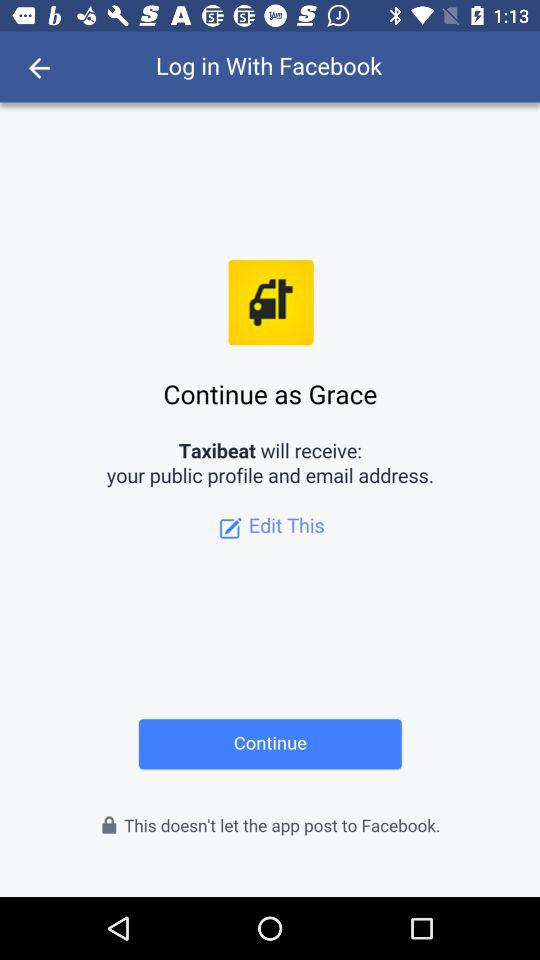Through what application are we logging in? You are logging in through "Facebook". 